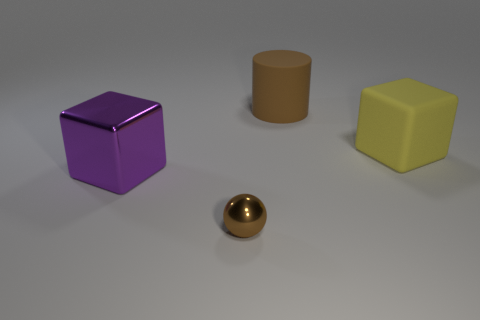Add 1 big brown things. How many objects exist? 5 Subtract all cylinders. How many objects are left? 3 Subtract 0 red blocks. How many objects are left? 4 Subtract all brown rubber things. Subtract all cubes. How many objects are left? 1 Add 1 big purple metallic things. How many big purple metallic things are left? 2 Add 3 yellow matte blocks. How many yellow matte blocks exist? 4 